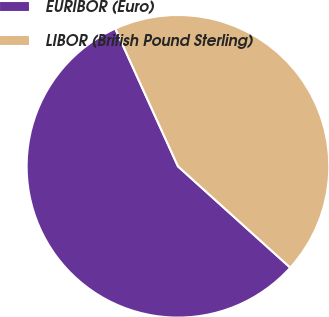Convert chart. <chart><loc_0><loc_0><loc_500><loc_500><pie_chart><fcel>EURIBOR (Euro)<fcel>LIBOR (British Pound Sterling)<nl><fcel>56.52%<fcel>43.48%<nl></chart> 